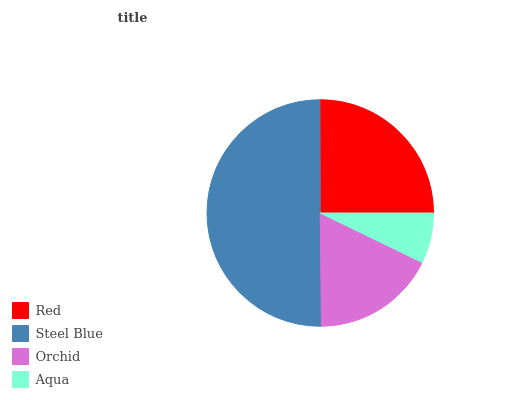Is Aqua the minimum?
Answer yes or no. Yes. Is Steel Blue the maximum?
Answer yes or no. Yes. Is Orchid the minimum?
Answer yes or no. No. Is Orchid the maximum?
Answer yes or no. No. Is Steel Blue greater than Orchid?
Answer yes or no. Yes. Is Orchid less than Steel Blue?
Answer yes or no. Yes. Is Orchid greater than Steel Blue?
Answer yes or no. No. Is Steel Blue less than Orchid?
Answer yes or no. No. Is Red the high median?
Answer yes or no. Yes. Is Orchid the low median?
Answer yes or no. Yes. Is Steel Blue the high median?
Answer yes or no. No. Is Red the low median?
Answer yes or no. No. 